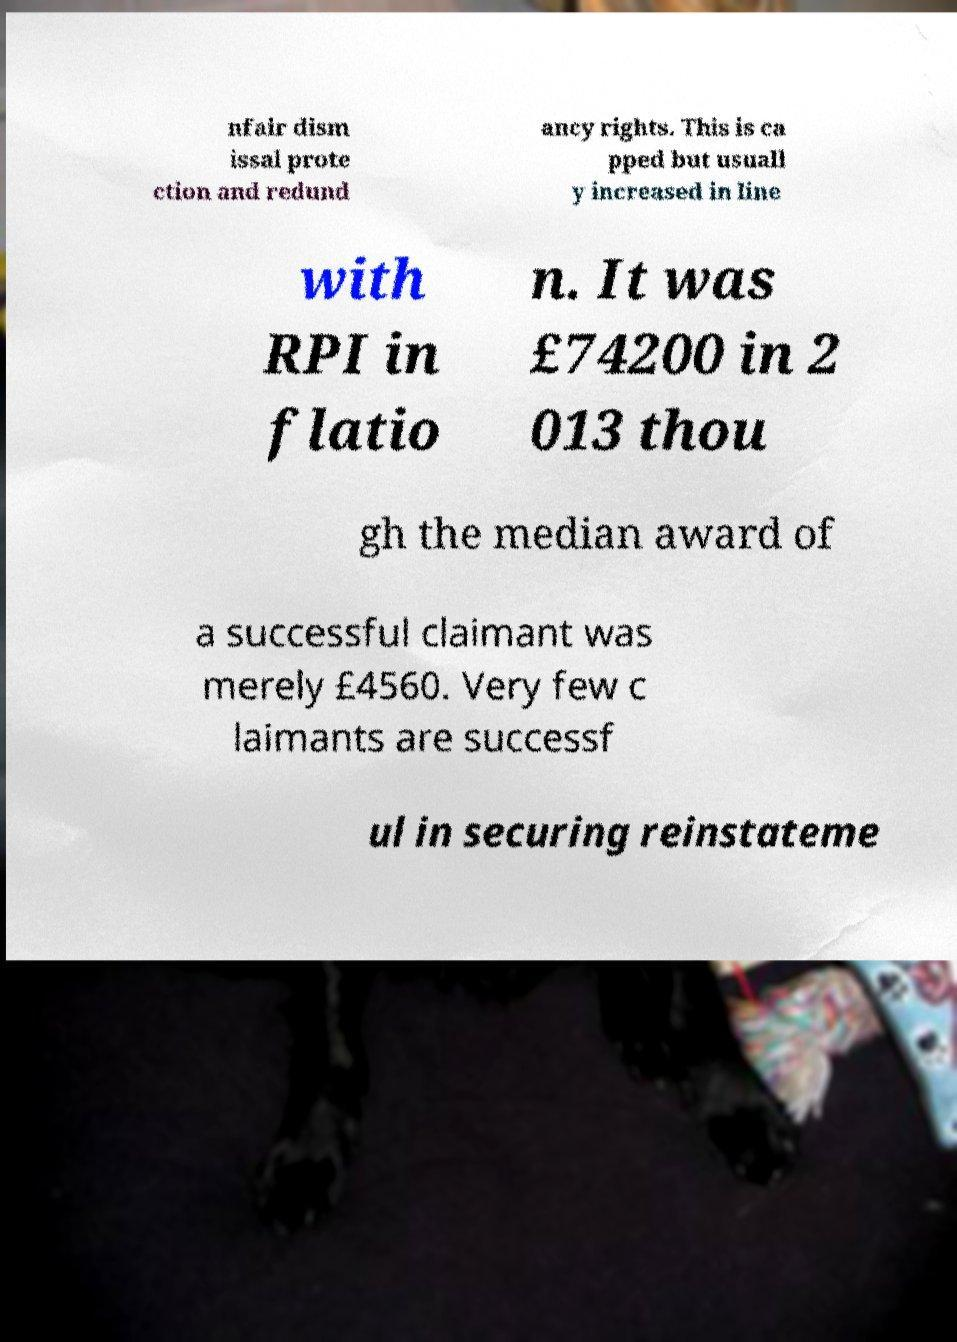Please identify and transcribe the text found in this image. nfair dism issal prote ction and redund ancy rights. This is ca pped but usuall y increased in line with RPI in flatio n. It was £74200 in 2 013 thou gh the median award of a successful claimant was merely £4560. Very few c laimants are successf ul in securing reinstateme 